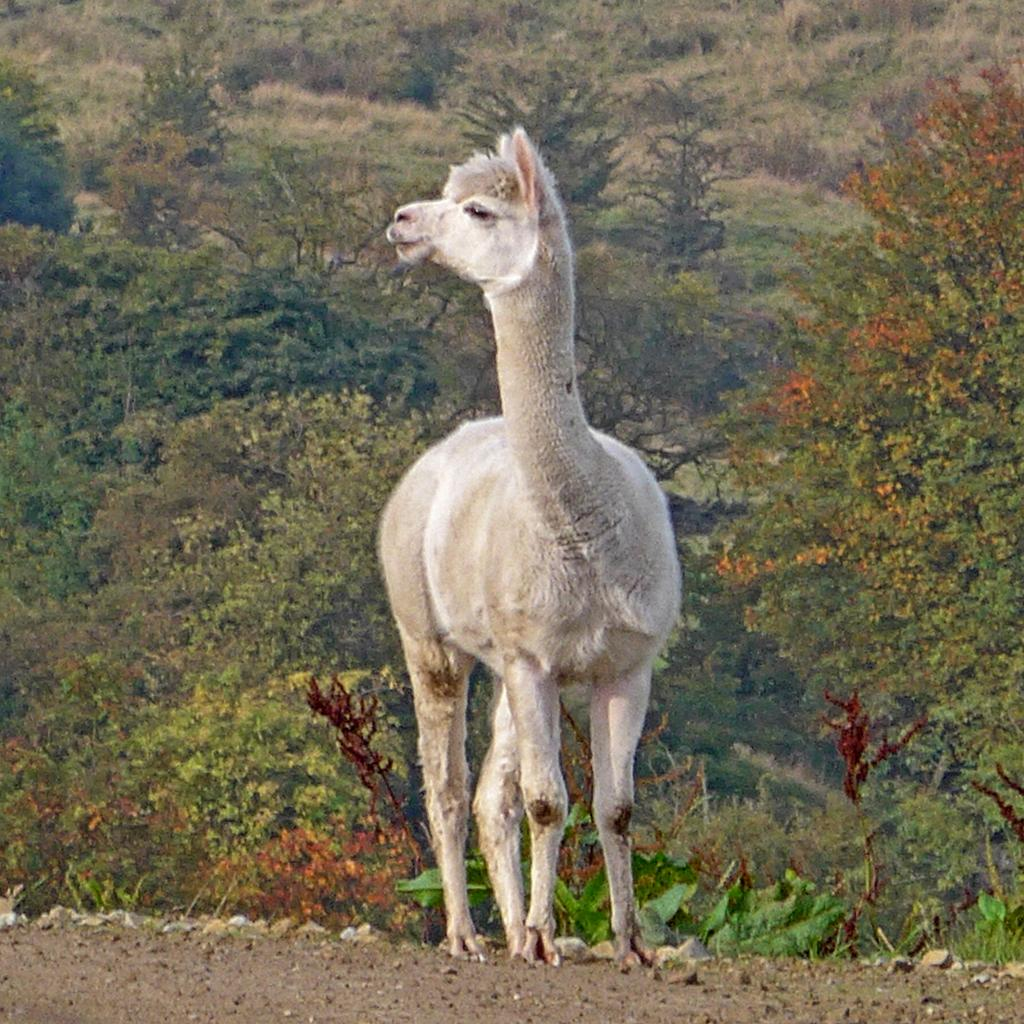What type of living organism can be seen in the image? There is an animal in the image. What is visible beneath the animal's feet? The ground is visible in the image. What type of natural features are present in the image? There are rocks, plants, trees, and grass in the image. What type of tramp can be seen in the image? There is no tramp present in the image. What achievements has the cow in the image accomplished? There is no cow present in the image, and therefore no achievements can be attributed to it. 